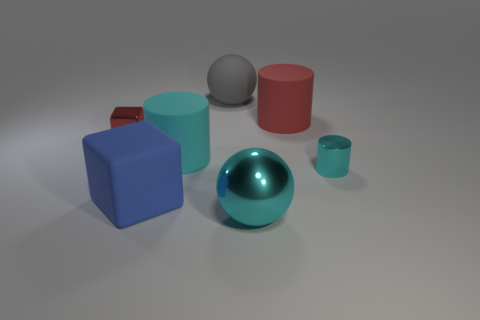Can you tell me the different colors visible in the objects shown? Certainly! The objects display a range of colors: there's a blue cube, a crimson cube, a teal cylinder, a gray sphere, a shiny blue sphere, and a small teal cup. 